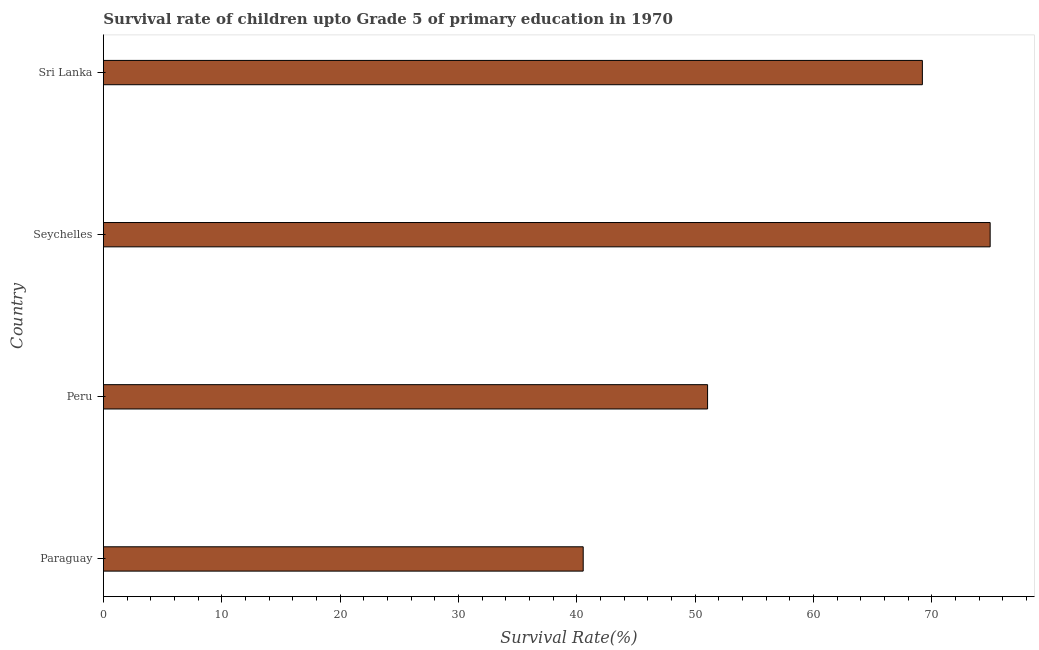What is the title of the graph?
Provide a succinct answer. Survival rate of children upto Grade 5 of primary education in 1970 . What is the label or title of the X-axis?
Offer a terse response. Survival Rate(%). What is the survival rate in Sri Lanka?
Keep it short and to the point. 69.19. Across all countries, what is the maximum survival rate?
Offer a very short reply. 74.92. Across all countries, what is the minimum survival rate?
Make the answer very short. 40.54. In which country was the survival rate maximum?
Keep it short and to the point. Seychelles. In which country was the survival rate minimum?
Make the answer very short. Paraguay. What is the sum of the survival rate?
Your response must be concise. 235.69. What is the difference between the survival rate in Peru and Seychelles?
Ensure brevity in your answer.  -23.87. What is the average survival rate per country?
Offer a terse response. 58.92. What is the median survival rate?
Offer a terse response. 60.12. What is the ratio of the survival rate in Peru to that in Seychelles?
Give a very brief answer. 0.68. Is the survival rate in Paraguay less than that in Sri Lanka?
Your answer should be very brief. Yes. Is the difference between the survival rate in Seychelles and Sri Lanka greater than the difference between any two countries?
Your answer should be compact. No. What is the difference between the highest and the second highest survival rate?
Provide a succinct answer. 5.73. Is the sum of the survival rate in Paraguay and Peru greater than the maximum survival rate across all countries?
Keep it short and to the point. Yes. What is the difference between the highest and the lowest survival rate?
Offer a very short reply. 34.38. How many countries are there in the graph?
Provide a short and direct response. 4. What is the Survival Rate(%) in Paraguay?
Provide a succinct answer. 40.54. What is the Survival Rate(%) in Peru?
Keep it short and to the point. 51.04. What is the Survival Rate(%) of Seychelles?
Make the answer very short. 74.92. What is the Survival Rate(%) in Sri Lanka?
Your answer should be compact. 69.19. What is the difference between the Survival Rate(%) in Paraguay and Peru?
Your response must be concise. -10.51. What is the difference between the Survival Rate(%) in Paraguay and Seychelles?
Offer a terse response. -34.38. What is the difference between the Survival Rate(%) in Paraguay and Sri Lanka?
Make the answer very short. -28.65. What is the difference between the Survival Rate(%) in Peru and Seychelles?
Your answer should be very brief. -23.87. What is the difference between the Survival Rate(%) in Peru and Sri Lanka?
Offer a very short reply. -18.15. What is the difference between the Survival Rate(%) in Seychelles and Sri Lanka?
Offer a very short reply. 5.73. What is the ratio of the Survival Rate(%) in Paraguay to that in Peru?
Provide a short and direct response. 0.79. What is the ratio of the Survival Rate(%) in Paraguay to that in Seychelles?
Provide a succinct answer. 0.54. What is the ratio of the Survival Rate(%) in Paraguay to that in Sri Lanka?
Keep it short and to the point. 0.59. What is the ratio of the Survival Rate(%) in Peru to that in Seychelles?
Give a very brief answer. 0.68. What is the ratio of the Survival Rate(%) in Peru to that in Sri Lanka?
Provide a succinct answer. 0.74. What is the ratio of the Survival Rate(%) in Seychelles to that in Sri Lanka?
Your response must be concise. 1.08. 